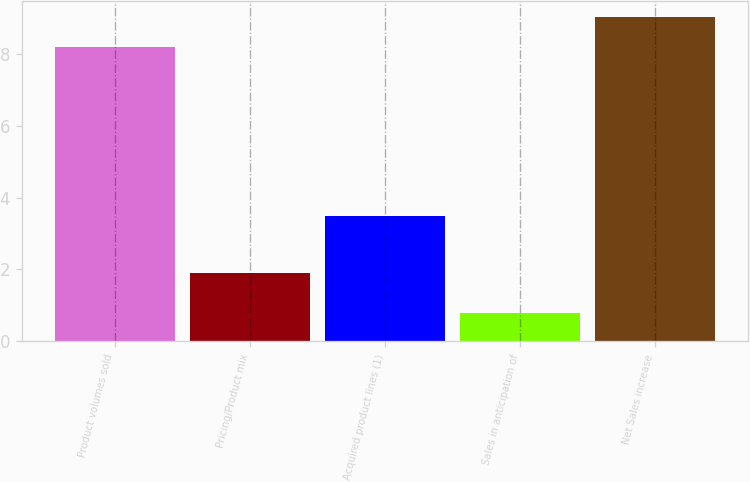Convert chart. <chart><loc_0><loc_0><loc_500><loc_500><bar_chart><fcel>Product volumes sold<fcel>Pricing/Product mix<fcel>Acquired product lines (1)<fcel>Sales in anticipation of<fcel>Net Sales increase<nl><fcel>8.2<fcel>1.9<fcel>3.5<fcel>0.8<fcel>9.02<nl></chart> 